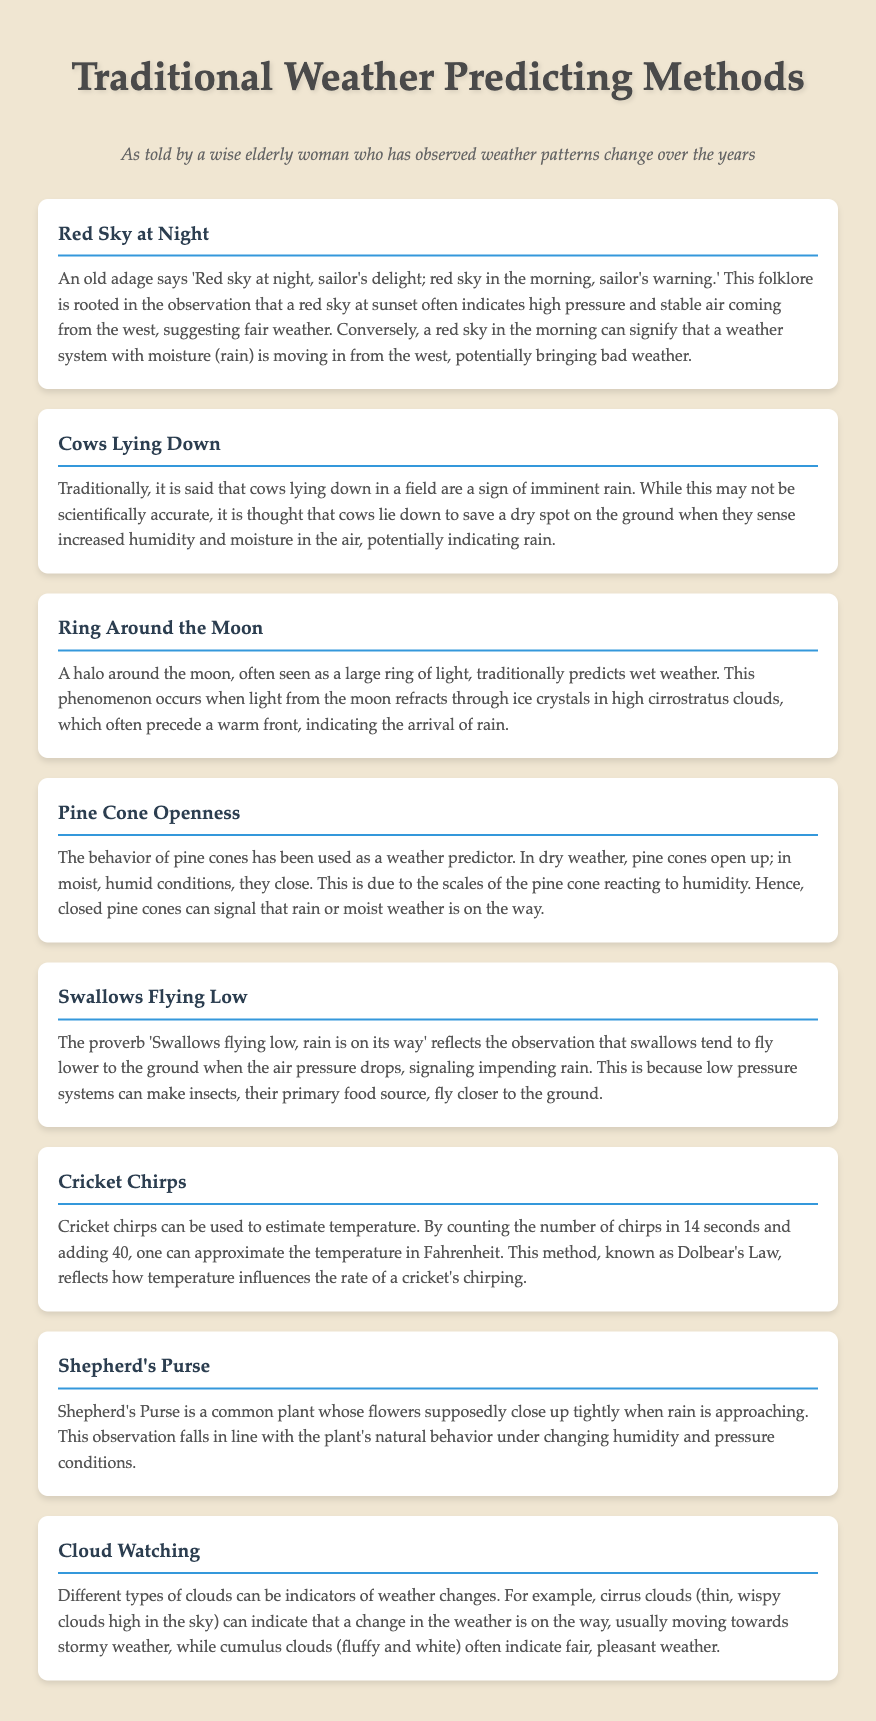What does "Red Sky at Night" indicate? This adage suggests that a red sky at sunset indicates high pressure and stable air, suggesting fair weather.
Answer: Fair weather What does it mean if cows are lying down? It is traditionally believed that cows lying down indicate imminent rain.
Answer: Imminent rain What does a ring around the moon predict? A halo around the moon traditionally predicts wet weather.
Answer: Wet weather How do pine cones behave in dry weather? In dry weather, pine cones open up.
Answer: Open up What does low-flying swallows signal? Swallows flying low signals impending rain due to lower air pressure.
Answer: Impending rain What can cricket chirps estimate? Cricket chirps can be used to estimate temperature.
Answer: Temperature What happens to Shepherd's Purse flowers before it rains? Shepherd's Purse flowers close tightly when rain is approaching.
Answer: Close tightly Which type of clouds usually indicates stormy weather? Cirrus clouds can indicate that a change in weather is coming, usually stormy weather.
Answer: Cirrus clouds 